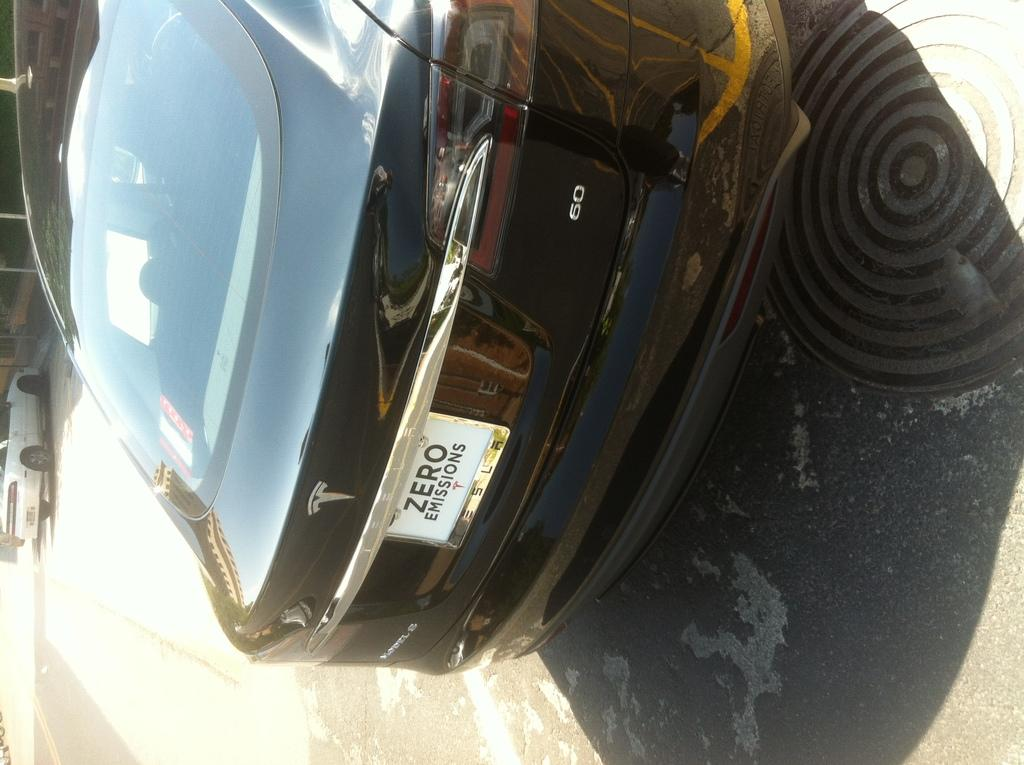What is the main subject in the center of the image? There is a car parked in the center of the image. Where is the car parked? The car is parked on the road. Are there any other cars visible in the image? Yes, there is another car parked on the left side of the image. How is the car on the left side parked? The car on the left side is parked aside. What type of button can be seen on the car's dashboard in the image? There is no button visible on the car's dashboard in the image. What class of car is parked on the left side of the image? The provided facts do not mention the class or model of the cars, so it cannot be determined from the image. 